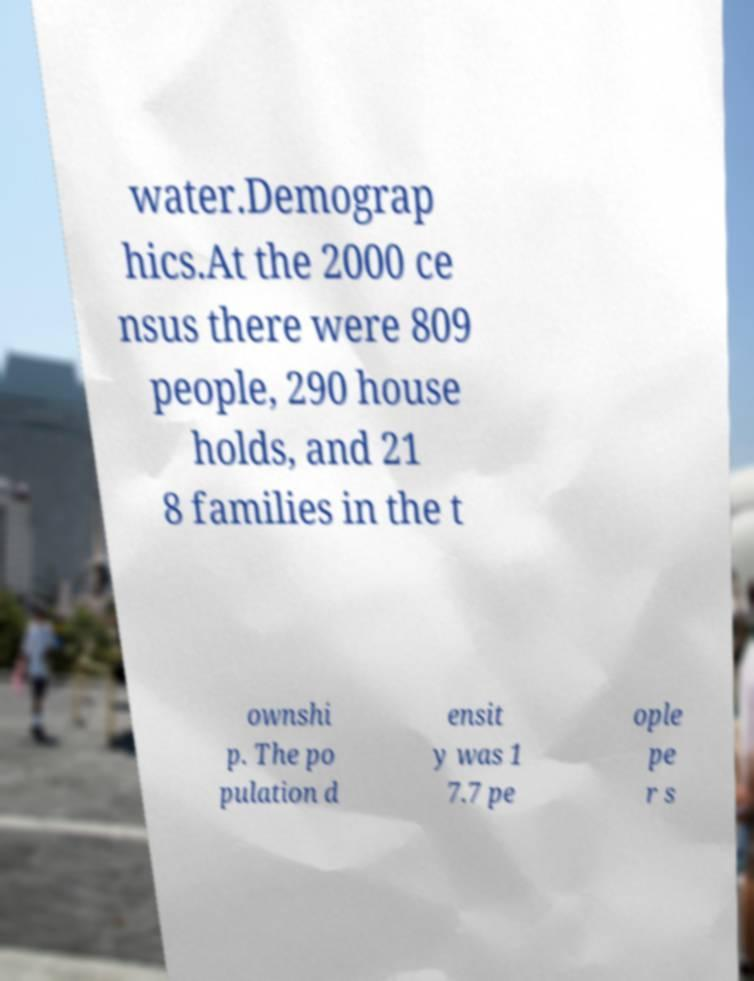There's text embedded in this image that I need extracted. Can you transcribe it verbatim? water.Demograp hics.At the 2000 ce nsus there were 809 people, 290 house holds, and 21 8 families in the t ownshi p. The po pulation d ensit y was 1 7.7 pe ople pe r s 